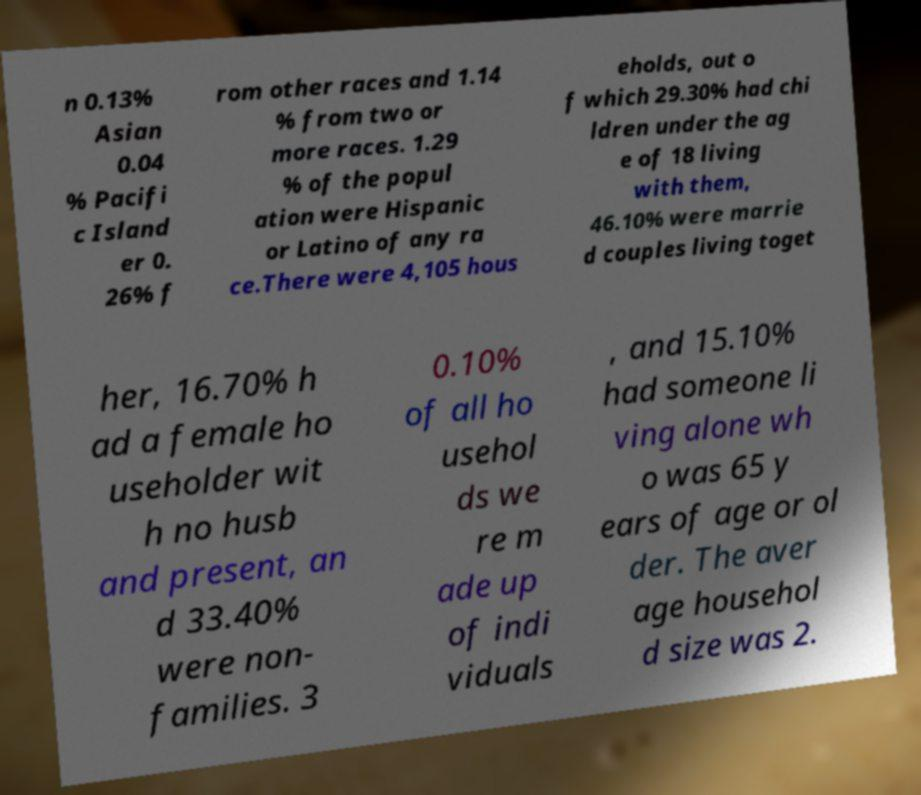Can you read and provide the text displayed in the image?This photo seems to have some interesting text. Can you extract and type it out for me? n 0.13% Asian 0.04 % Pacifi c Island er 0. 26% f rom other races and 1.14 % from two or more races. 1.29 % of the popul ation were Hispanic or Latino of any ra ce.There were 4,105 hous eholds, out o f which 29.30% had chi ldren under the ag e of 18 living with them, 46.10% were marrie d couples living toget her, 16.70% h ad a female ho useholder wit h no husb and present, an d 33.40% were non- families. 3 0.10% of all ho usehol ds we re m ade up of indi viduals , and 15.10% had someone li ving alone wh o was 65 y ears of age or ol der. The aver age househol d size was 2. 